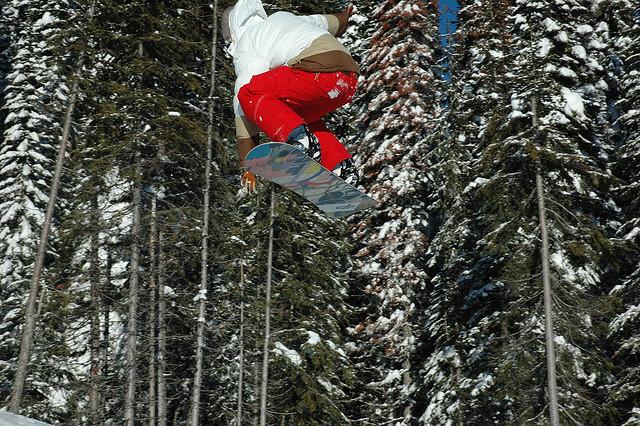Is there blue paint on the tree?
Keep it brief. No. What is the type of street art that the snowboard design looks like?
Give a very brief answer. Graffiti. Why is this guy flying into the air?
Give a very brief answer. Snowboarding. 